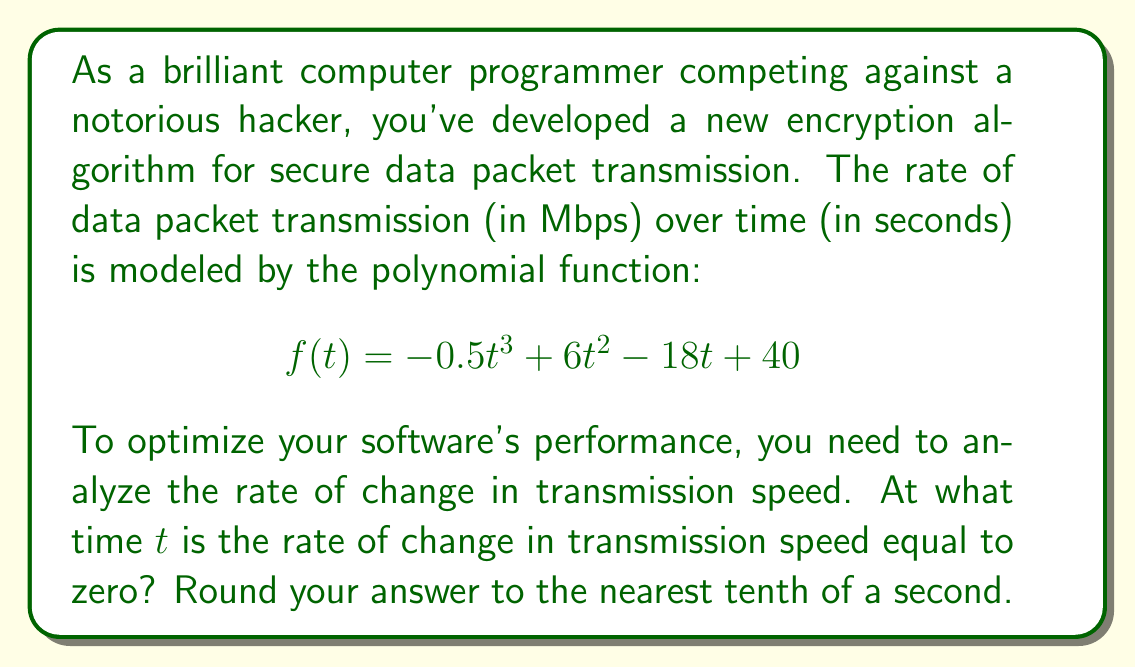Show me your answer to this math problem. To solve this problem, we need to follow these steps:

1) The rate of change in transmission speed is given by the first derivative of the function $f(t)$. Let's call this $f'(t)$.

2) Calculate $f'(t)$ using the power rule:
   $$f'(t) = -1.5t^2 + 12t - 18$$

3) To find when the rate of change is zero, we need to solve the equation:
   $$f'(t) = 0$$
   $$-1.5t^2 + 12t - 18 = 0$$

4) This is a quadratic equation. We can solve it using the quadratic formula:
   $$t = \frac{-b \pm \sqrt{b^2 - 4ac}}{2a}$$
   where $a = -1.5$, $b = 12$, and $c = -18$

5) Substituting these values:
   $$t = \frac{-12 \pm \sqrt{12^2 - 4(-1.5)(-18)}}{2(-1.5)}$$
   $$= \frac{-12 \pm \sqrt{144 - 108}}{-3}$$
   $$= \frac{-12 \pm \sqrt{36}}{-3}$$
   $$= \frac{-12 \pm 6}{-3}$$

6) This gives us two solutions:
   $$t = \frac{-12 + 6}{-3} = 2$$ or $$t = \frac{-12 - 6}{-3} = 6$$

7) Rounding to the nearest tenth of a second, both solutions remain the same.

Therefore, the rate of change in transmission speed is zero at $t = 2.0$ seconds and $t = 6.0$ seconds.
Answer: The rate of change in transmission speed is equal to zero at $t = 2.0$ seconds and $t = 6.0$ seconds. 